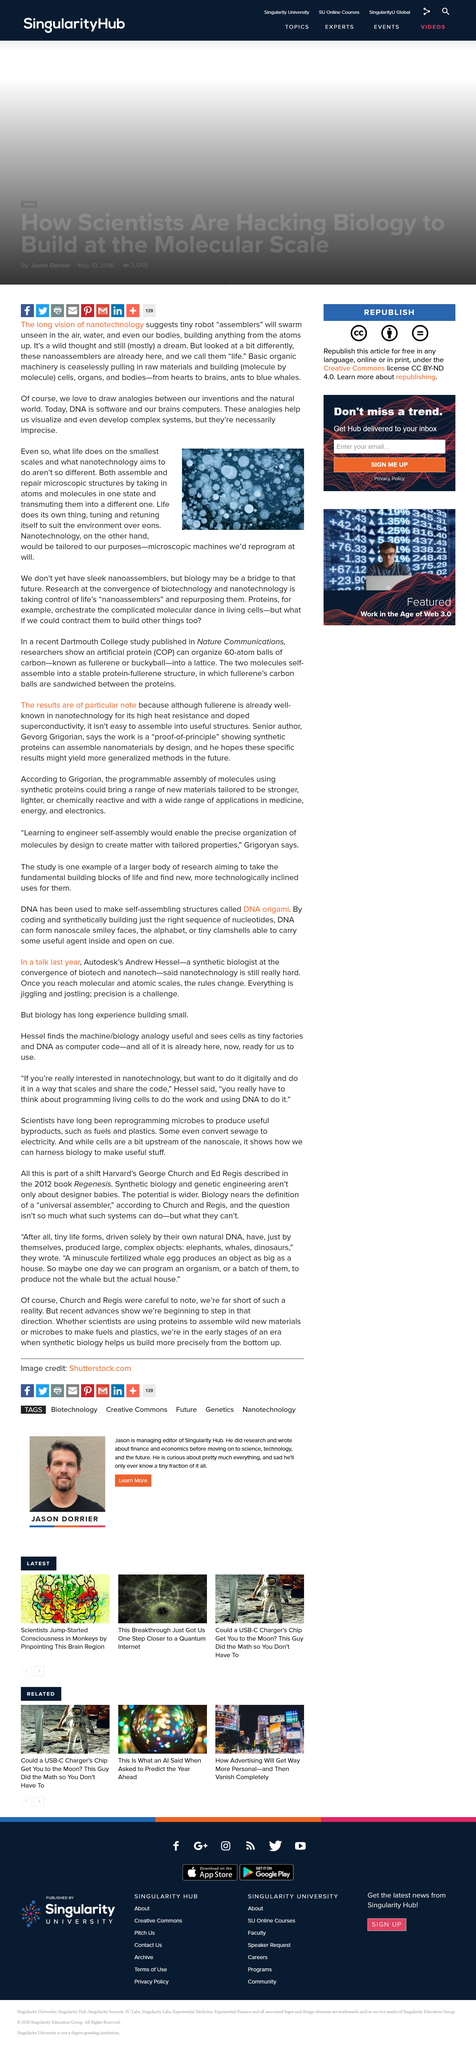List a handful of essential elements in this visual. It is suggested that the activities and functions that life performs on a small scale are similar to the objectives of nanotechnology. In other words, nanotechnology aims to replicate and manipulate materials and structures on a very small scale, just like life does in its natural processes. Nanotechnology can be reprogrammed, and it will. Nanotechnology, with its long-term vision of tiny robot assemblers, suggests the potential for swarms of robots to assemble in the air. 